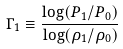Convert formula to latex. <formula><loc_0><loc_0><loc_500><loc_500>\Gamma _ { 1 } \equiv \frac { \log ( P _ { 1 } / P _ { 0 } ) } { \log ( \rho _ { 1 } / \rho _ { 0 } ) }</formula> 